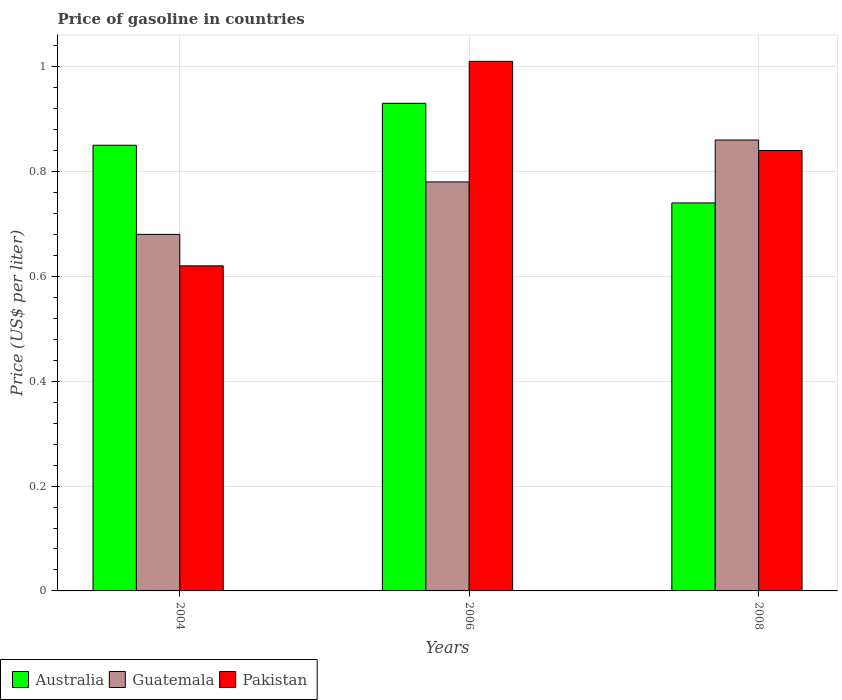Are the number of bars per tick equal to the number of legend labels?
Your response must be concise. Yes. How many bars are there on the 2nd tick from the right?
Keep it short and to the point. 3. In how many cases, is the number of bars for a given year not equal to the number of legend labels?
Ensure brevity in your answer.  0. Across all years, what is the minimum price of gasoline in Australia?
Ensure brevity in your answer.  0.74. In which year was the price of gasoline in Australia maximum?
Provide a short and direct response. 2006. What is the total price of gasoline in Australia in the graph?
Offer a very short reply. 2.52. What is the difference between the price of gasoline in Guatemala in 2004 and that in 2006?
Your answer should be very brief. -0.1. What is the difference between the price of gasoline in Guatemala in 2008 and the price of gasoline in Australia in 2004?
Provide a succinct answer. 0.01. What is the average price of gasoline in Pakistan per year?
Your answer should be compact. 0.82. In the year 2004, what is the difference between the price of gasoline in Australia and price of gasoline in Guatemala?
Your response must be concise. 0.17. What is the ratio of the price of gasoline in Guatemala in 2004 to that in 2008?
Ensure brevity in your answer.  0.79. What is the difference between the highest and the second highest price of gasoline in Pakistan?
Provide a short and direct response. 0.17. What is the difference between the highest and the lowest price of gasoline in Guatemala?
Provide a succinct answer. 0.18. In how many years, is the price of gasoline in Guatemala greater than the average price of gasoline in Guatemala taken over all years?
Your answer should be very brief. 2. Is the sum of the price of gasoline in Pakistan in 2004 and 2008 greater than the maximum price of gasoline in Guatemala across all years?
Make the answer very short. Yes. What does the 2nd bar from the left in 2006 represents?
Your response must be concise. Guatemala. Are all the bars in the graph horizontal?
Provide a succinct answer. No. What is the difference between two consecutive major ticks on the Y-axis?
Offer a very short reply. 0.2. Are the values on the major ticks of Y-axis written in scientific E-notation?
Ensure brevity in your answer.  No. Does the graph contain any zero values?
Ensure brevity in your answer.  No. Does the graph contain grids?
Your answer should be compact. Yes. How are the legend labels stacked?
Ensure brevity in your answer.  Horizontal. What is the title of the graph?
Offer a very short reply. Price of gasoline in countries. What is the label or title of the X-axis?
Ensure brevity in your answer.  Years. What is the label or title of the Y-axis?
Make the answer very short. Price (US$ per liter). What is the Price (US$ per liter) of Guatemala in 2004?
Keep it short and to the point. 0.68. What is the Price (US$ per liter) of Pakistan in 2004?
Ensure brevity in your answer.  0.62. What is the Price (US$ per liter) of Guatemala in 2006?
Your answer should be very brief. 0.78. What is the Price (US$ per liter) of Australia in 2008?
Provide a succinct answer. 0.74. What is the Price (US$ per liter) of Guatemala in 2008?
Your answer should be compact. 0.86. What is the Price (US$ per liter) in Pakistan in 2008?
Provide a short and direct response. 0.84. Across all years, what is the maximum Price (US$ per liter) of Australia?
Offer a very short reply. 0.93. Across all years, what is the maximum Price (US$ per liter) of Guatemala?
Your answer should be compact. 0.86. Across all years, what is the maximum Price (US$ per liter) of Pakistan?
Keep it short and to the point. 1.01. Across all years, what is the minimum Price (US$ per liter) of Australia?
Provide a short and direct response. 0.74. Across all years, what is the minimum Price (US$ per liter) in Guatemala?
Your response must be concise. 0.68. Across all years, what is the minimum Price (US$ per liter) in Pakistan?
Offer a terse response. 0.62. What is the total Price (US$ per liter) of Australia in the graph?
Your response must be concise. 2.52. What is the total Price (US$ per liter) of Guatemala in the graph?
Give a very brief answer. 2.32. What is the total Price (US$ per liter) of Pakistan in the graph?
Ensure brevity in your answer.  2.47. What is the difference between the Price (US$ per liter) of Australia in 2004 and that in 2006?
Your answer should be very brief. -0.08. What is the difference between the Price (US$ per liter) in Guatemala in 2004 and that in 2006?
Provide a succinct answer. -0.1. What is the difference between the Price (US$ per liter) in Pakistan in 2004 and that in 2006?
Your answer should be compact. -0.39. What is the difference between the Price (US$ per liter) of Australia in 2004 and that in 2008?
Your answer should be compact. 0.11. What is the difference between the Price (US$ per liter) in Guatemala in 2004 and that in 2008?
Your answer should be very brief. -0.18. What is the difference between the Price (US$ per liter) of Pakistan in 2004 and that in 2008?
Give a very brief answer. -0.22. What is the difference between the Price (US$ per liter) in Australia in 2006 and that in 2008?
Your response must be concise. 0.19. What is the difference between the Price (US$ per liter) of Guatemala in 2006 and that in 2008?
Your answer should be compact. -0.08. What is the difference between the Price (US$ per liter) in Pakistan in 2006 and that in 2008?
Make the answer very short. 0.17. What is the difference between the Price (US$ per liter) of Australia in 2004 and the Price (US$ per liter) of Guatemala in 2006?
Make the answer very short. 0.07. What is the difference between the Price (US$ per liter) in Australia in 2004 and the Price (US$ per liter) in Pakistan in 2006?
Keep it short and to the point. -0.16. What is the difference between the Price (US$ per liter) of Guatemala in 2004 and the Price (US$ per liter) of Pakistan in 2006?
Offer a very short reply. -0.33. What is the difference between the Price (US$ per liter) in Australia in 2004 and the Price (US$ per liter) in Guatemala in 2008?
Your answer should be very brief. -0.01. What is the difference between the Price (US$ per liter) in Australia in 2004 and the Price (US$ per liter) in Pakistan in 2008?
Offer a very short reply. 0.01. What is the difference between the Price (US$ per liter) in Guatemala in 2004 and the Price (US$ per liter) in Pakistan in 2008?
Offer a very short reply. -0.16. What is the difference between the Price (US$ per liter) of Australia in 2006 and the Price (US$ per liter) of Guatemala in 2008?
Offer a very short reply. 0.07. What is the difference between the Price (US$ per liter) in Australia in 2006 and the Price (US$ per liter) in Pakistan in 2008?
Provide a short and direct response. 0.09. What is the difference between the Price (US$ per liter) of Guatemala in 2006 and the Price (US$ per liter) of Pakistan in 2008?
Give a very brief answer. -0.06. What is the average Price (US$ per liter) in Australia per year?
Offer a very short reply. 0.84. What is the average Price (US$ per liter) of Guatemala per year?
Provide a short and direct response. 0.77. What is the average Price (US$ per liter) in Pakistan per year?
Your response must be concise. 0.82. In the year 2004, what is the difference between the Price (US$ per liter) in Australia and Price (US$ per liter) in Guatemala?
Offer a very short reply. 0.17. In the year 2004, what is the difference between the Price (US$ per liter) of Australia and Price (US$ per liter) of Pakistan?
Your answer should be very brief. 0.23. In the year 2006, what is the difference between the Price (US$ per liter) in Australia and Price (US$ per liter) in Pakistan?
Your answer should be compact. -0.08. In the year 2006, what is the difference between the Price (US$ per liter) in Guatemala and Price (US$ per liter) in Pakistan?
Keep it short and to the point. -0.23. In the year 2008, what is the difference between the Price (US$ per liter) of Australia and Price (US$ per liter) of Guatemala?
Make the answer very short. -0.12. In the year 2008, what is the difference between the Price (US$ per liter) in Guatemala and Price (US$ per liter) in Pakistan?
Your answer should be very brief. 0.02. What is the ratio of the Price (US$ per liter) in Australia in 2004 to that in 2006?
Your answer should be very brief. 0.91. What is the ratio of the Price (US$ per liter) in Guatemala in 2004 to that in 2006?
Provide a succinct answer. 0.87. What is the ratio of the Price (US$ per liter) in Pakistan in 2004 to that in 2006?
Your response must be concise. 0.61. What is the ratio of the Price (US$ per liter) of Australia in 2004 to that in 2008?
Your response must be concise. 1.15. What is the ratio of the Price (US$ per liter) in Guatemala in 2004 to that in 2008?
Provide a short and direct response. 0.79. What is the ratio of the Price (US$ per liter) of Pakistan in 2004 to that in 2008?
Your answer should be very brief. 0.74. What is the ratio of the Price (US$ per liter) of Australia in 2006 to that in 2008?
Ensure brevity in your answer.  1.26. What is the ratio of the Price (US$ per liter) in Guatemala in 2006 to that in 2008?
Offer a terse response. 0.91. What is the ratio of the Price (US$ per liter) in Pakistan in 2006 to that in 2008?
Give a very brief answer. 1.2. What is the difference between the highest and the second highest Price (US$ per liter) of Guatemala?
Keep it short and to the point. 0.08. What is the difference between the highest and the second highest Price (US$ per liter) in Pakistan?
Your answer should be compact. 0.17. What is the difference between the highest and the lowest Price (US$ per liter) of Australia?
Give a very brief answer. 0.19. What is the difference between the highest and the lowest Price (US$ per liter) of Guatemala?
Provide a succinct answer. 0.18. What is the difference between the highest and the lowest Price (US$ per liter) of Pakistan?
Offer a very short reply. 0.39. 